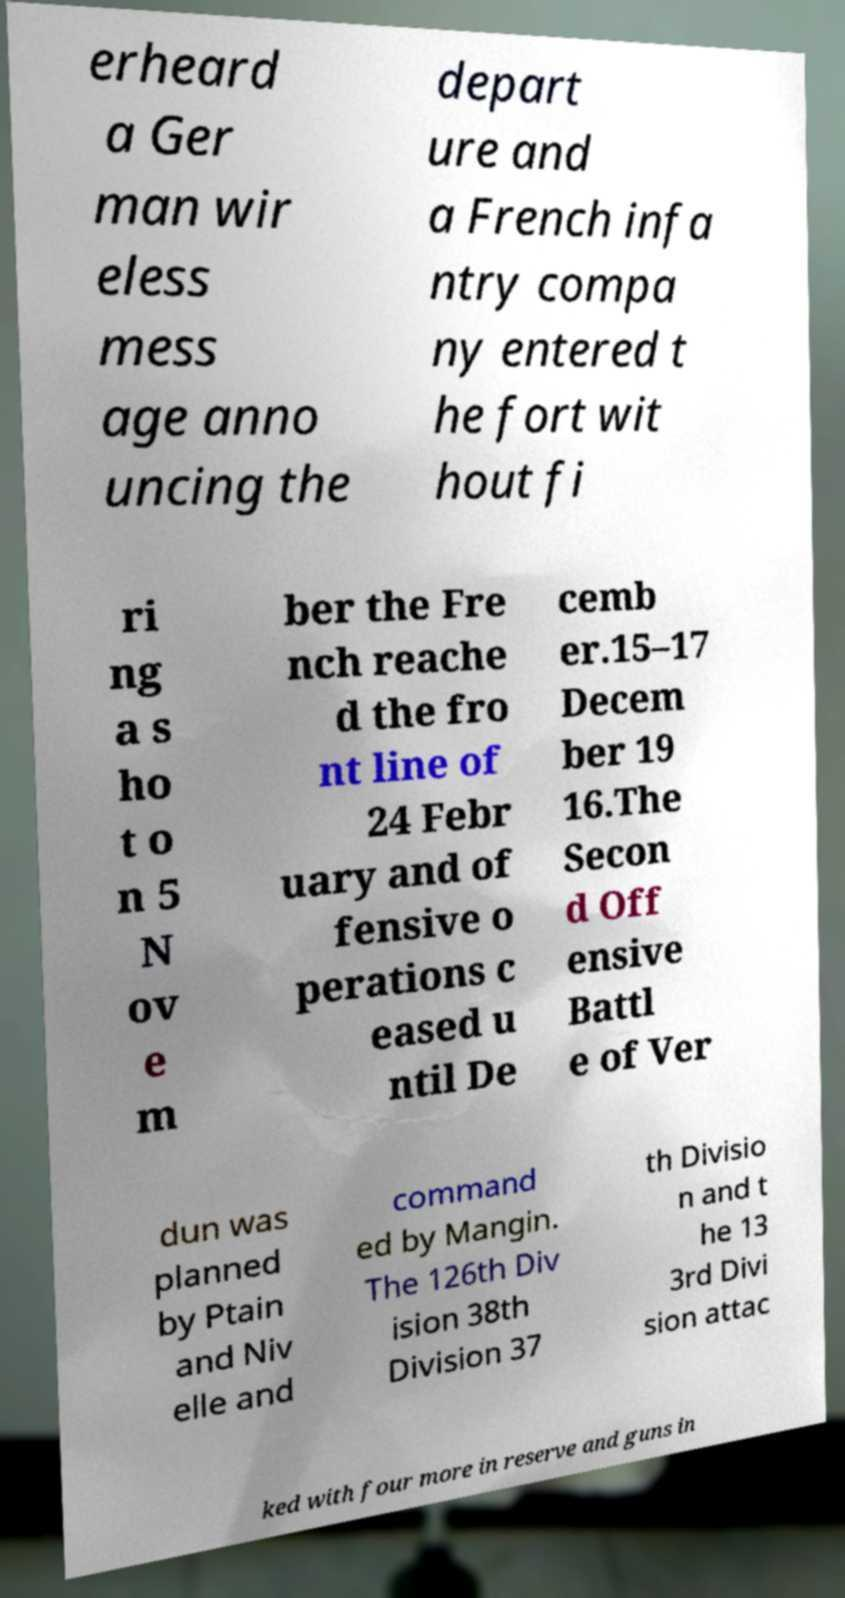What messages or text are displayed in this image? I need them in a readable, typed format. erheard a Ger man wir eless mess age anno uncing the depart ure and a French infa ntry compa ny entered t he fort wit hout fi ri ng a s ho t o n 5 N ov e m ber the Fre nch reache d the fro nt line of 24 Febr uary and of fensive o perations c eased u ntil De cemb er.15–17 Decem ber 19 16.The Secon d Off ensive Battl e of Ver dun was planned by Ptain and Niv elle and command ed by Mangin. The 126th Div ision 38th Division 37 th Divisio n and t he 13 3rd Divi sion attac ked with four more in reserve and guns in 